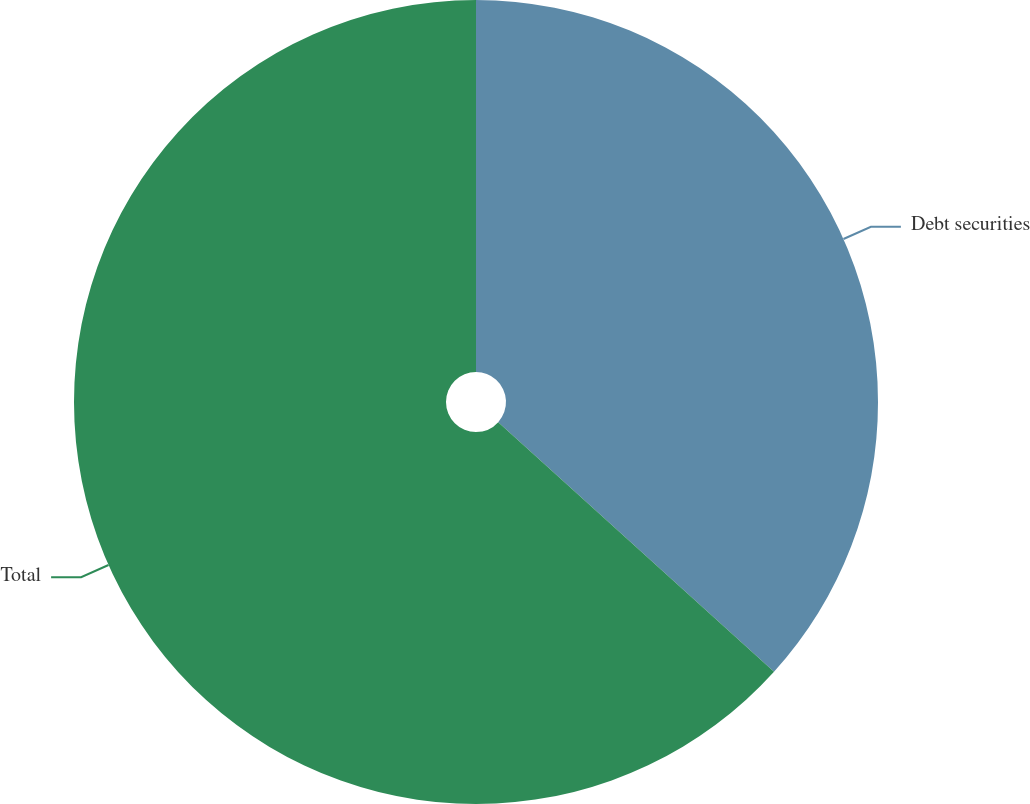Convert chart to OTSL. <chart><loc_0><loc_0><loc_500><loc_500><pie_chart><fcel>Debt securities<fcel>Total<nl><fcel>36.71%<fcel>63.29%<nl></chart> 